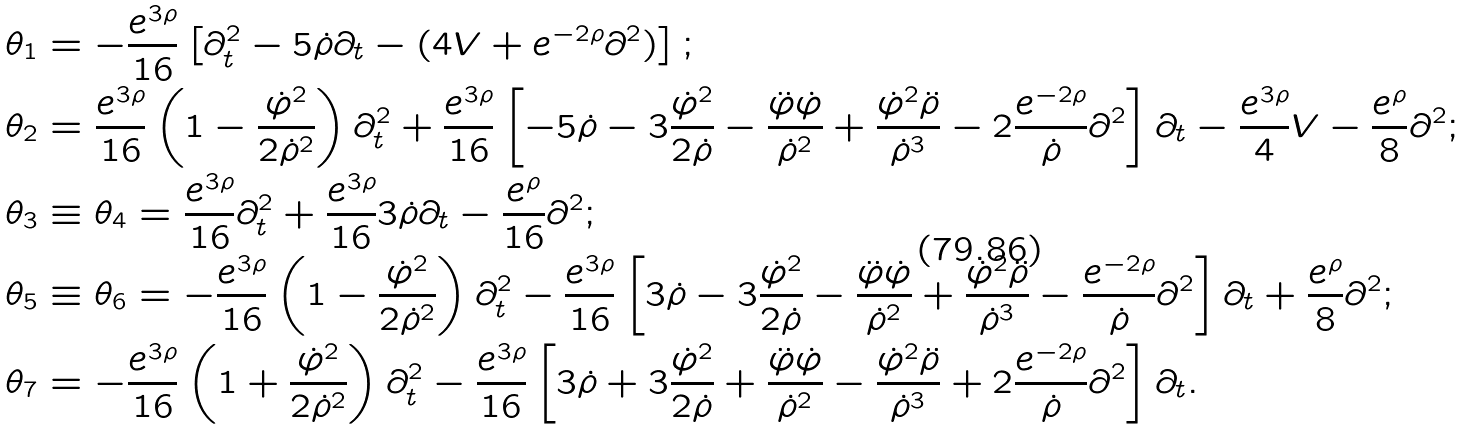<formula> <loc_0><loc_0><loc_500><loc_500>\theta _ { 1 } & = - \frac { e ^ { 3 \rho } } { 1 6 } \left [ \partial _ { t } ^ { 2 } - 5 \dot { \rho } \partial _ { t } - ( 4 V + e ^ { - 2 \rho } \partial ^ { 2 } ) \right ] ; \\ \theta _ { 2 } & = \frac { e ^ { 3 \rho } } { 1 6 } \left ( 1 - \frac { \dot { \varphi } ^ { 2 } } { 2 \dot { \rho } ^ { 2 } } \right ) \partial _ { t } ^ { 2 } + \frac { e ^ { 3 \rho } } { 1 6 } \left [ - 5 \dot { \rho } - 3 \frac { \dot { \varphi } ^ { 2 } } { 2 \dot { \rho } } - \frac { \ddot { \varphi } \dot { \varphi } } { \dot { \rho } ^ { 2 } } + \frac { \dot { \varphi } ^ { 2 } \ddot { \rho } } { \dot { \rho } ^ { 3 } } - 2 \frac { e ^ { - 2 \rho } } { \dot { \rho } } \partial ^ { 2 } \right ] \partial _ { t } - \frac { e ^ { 3 \rho } } { 4 } V - \frac { e ^ { \rho } } { 8 } \partial ^ { 2 } ; \\ \theta _ { 3 } & \equiv \theta _ { 4 } = \frac { e ^ { 3 \rho } } { 1 6 } \partial _ { t } ^ { 2 } + \frac { e ^ { 3 \rho } } { 1 6 } 3 \dot { \rho } \partial _ { t } - \frac { e ^ { \rho } } { 1 6 } \partial ^ { 2 } ; \\ \theta _ { 5 } & \equiv \theta _ { 6 } = - \frac { e ^ { 3 \rho } } { 1 6 } \left ( 1 - \frac { \dot { \varphi } ^ { 2 } } { 2 \dot { \rho } ^ { 2 } } \right ) \partial _ { t } ^ { 2 } - \frac { e ^ { 3 \rho } } { 1 6 } \left [ 3 \dot { \rho } - 3 \frac { \dot { \varphi } ^ { 2 } } { 2 \dot { \rho } } - \frac { \ddot { \varphi } \dot { \varphi } } { \dot { \rho } ^ { 2 } } + \frac { \dot { \varphi } ^ { 2 } \ddot { \rho } } { \dot { \rho } ^ { 3 } } - \frac { e ^ { - 2 \rho } } { \dot { \rho } } \partial ^ { 2 } \right ] \partial _ { t } + \frac { e ^ { \rho } } { 8 } \partial ^ { 2 } ; \\ \theta _ { 7 } & = - \frac { e ^ { 3 \rho } } { 1 6 } \left ( 1 + \frac { \dot { \varphi } ^ { 2 } } { 2 \dot { \rho } ^ { 2 } } \right ) \partial _ { t } ^ { 2 } - \frac { e ^ { 3 \rho } } { 1 6 } \left [ 3 \dot { \rho } + 3 \frac { \dot { \varphi } ^ { 2 } } { 2 \dot { \rho } } + \frac { \ddot { \varphi } \dot { \varphi } } { \dot { \rho } ^ { 2 } } - \frac { \dot { \varphi } ^ { 2 } \ddot { \rho } } { \dot { \rho } ^ { 3 } } + 2 \frac { e ^ { - 2 \rho } } { \dot { \rho } } \partial ^ { 2 } \right ] \partial _ { t } .</formula> 